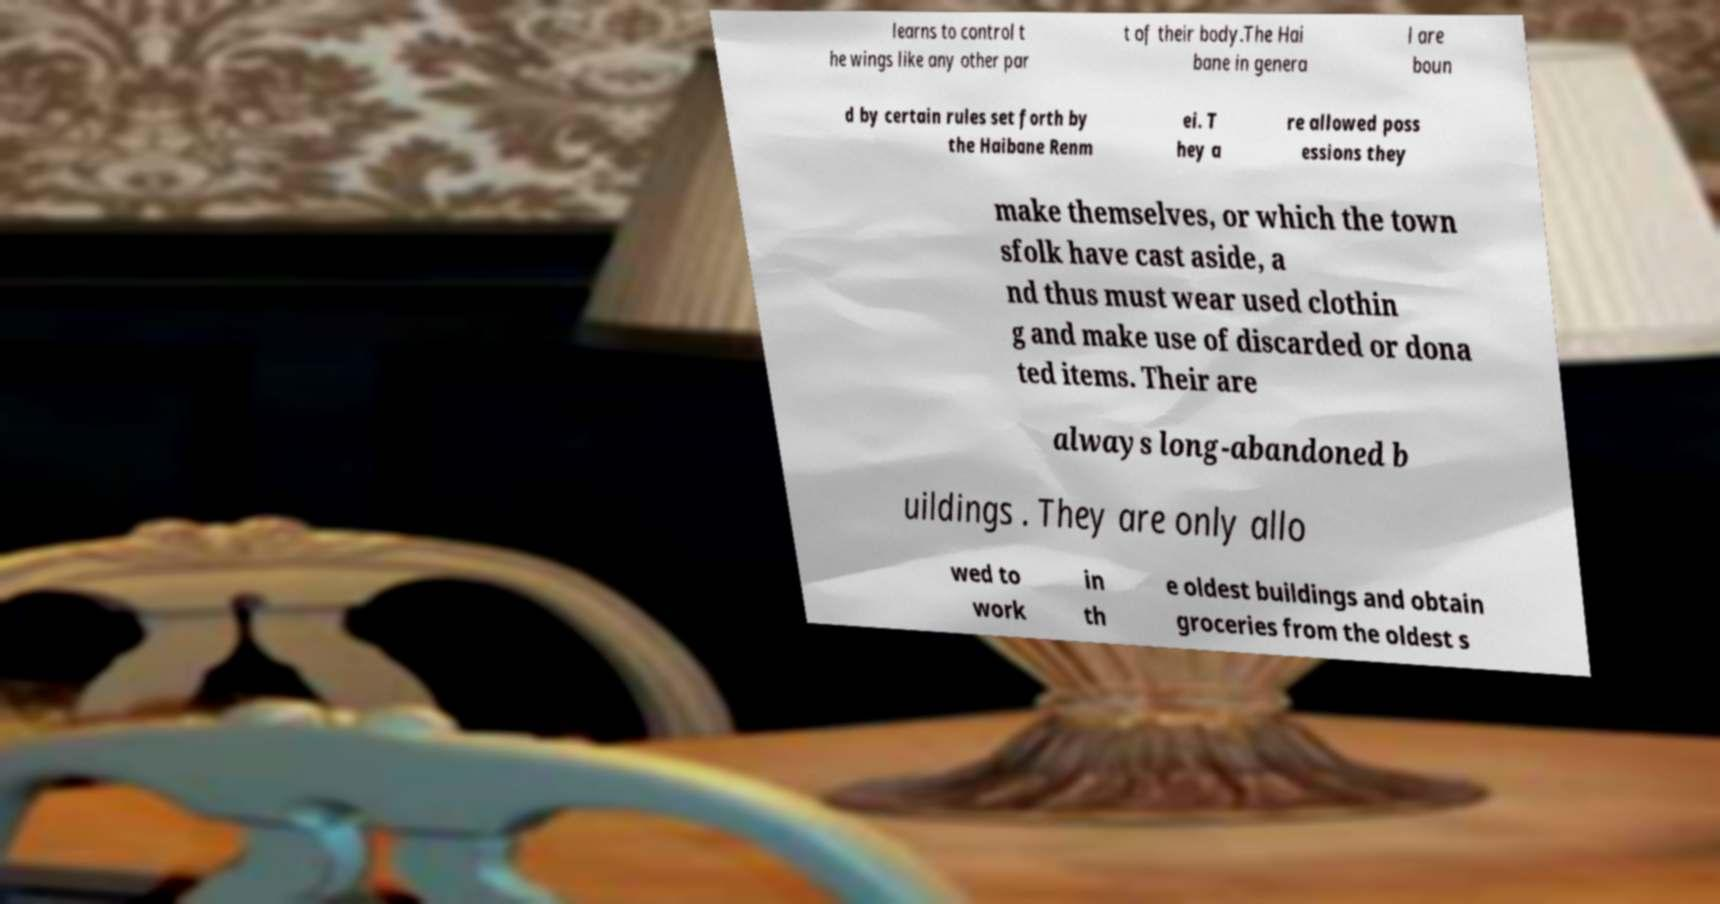Can you accurately transcribe the text from the provided image for me? learns to control t he wings like any other par t of their body.The Hai bane in genera l are boun d by certain rules set forth by the Haibane Renm ei. T hey a re allowed poss essions they make themselves, or which the town sfolk have cast aside, a nd thus must wear used clothin g and make use of discarded or dona ted items. Their are always long-abandoned b uildings . They are only allo wed to work in th e oldest buildings and obtain groceries from the oldest s 